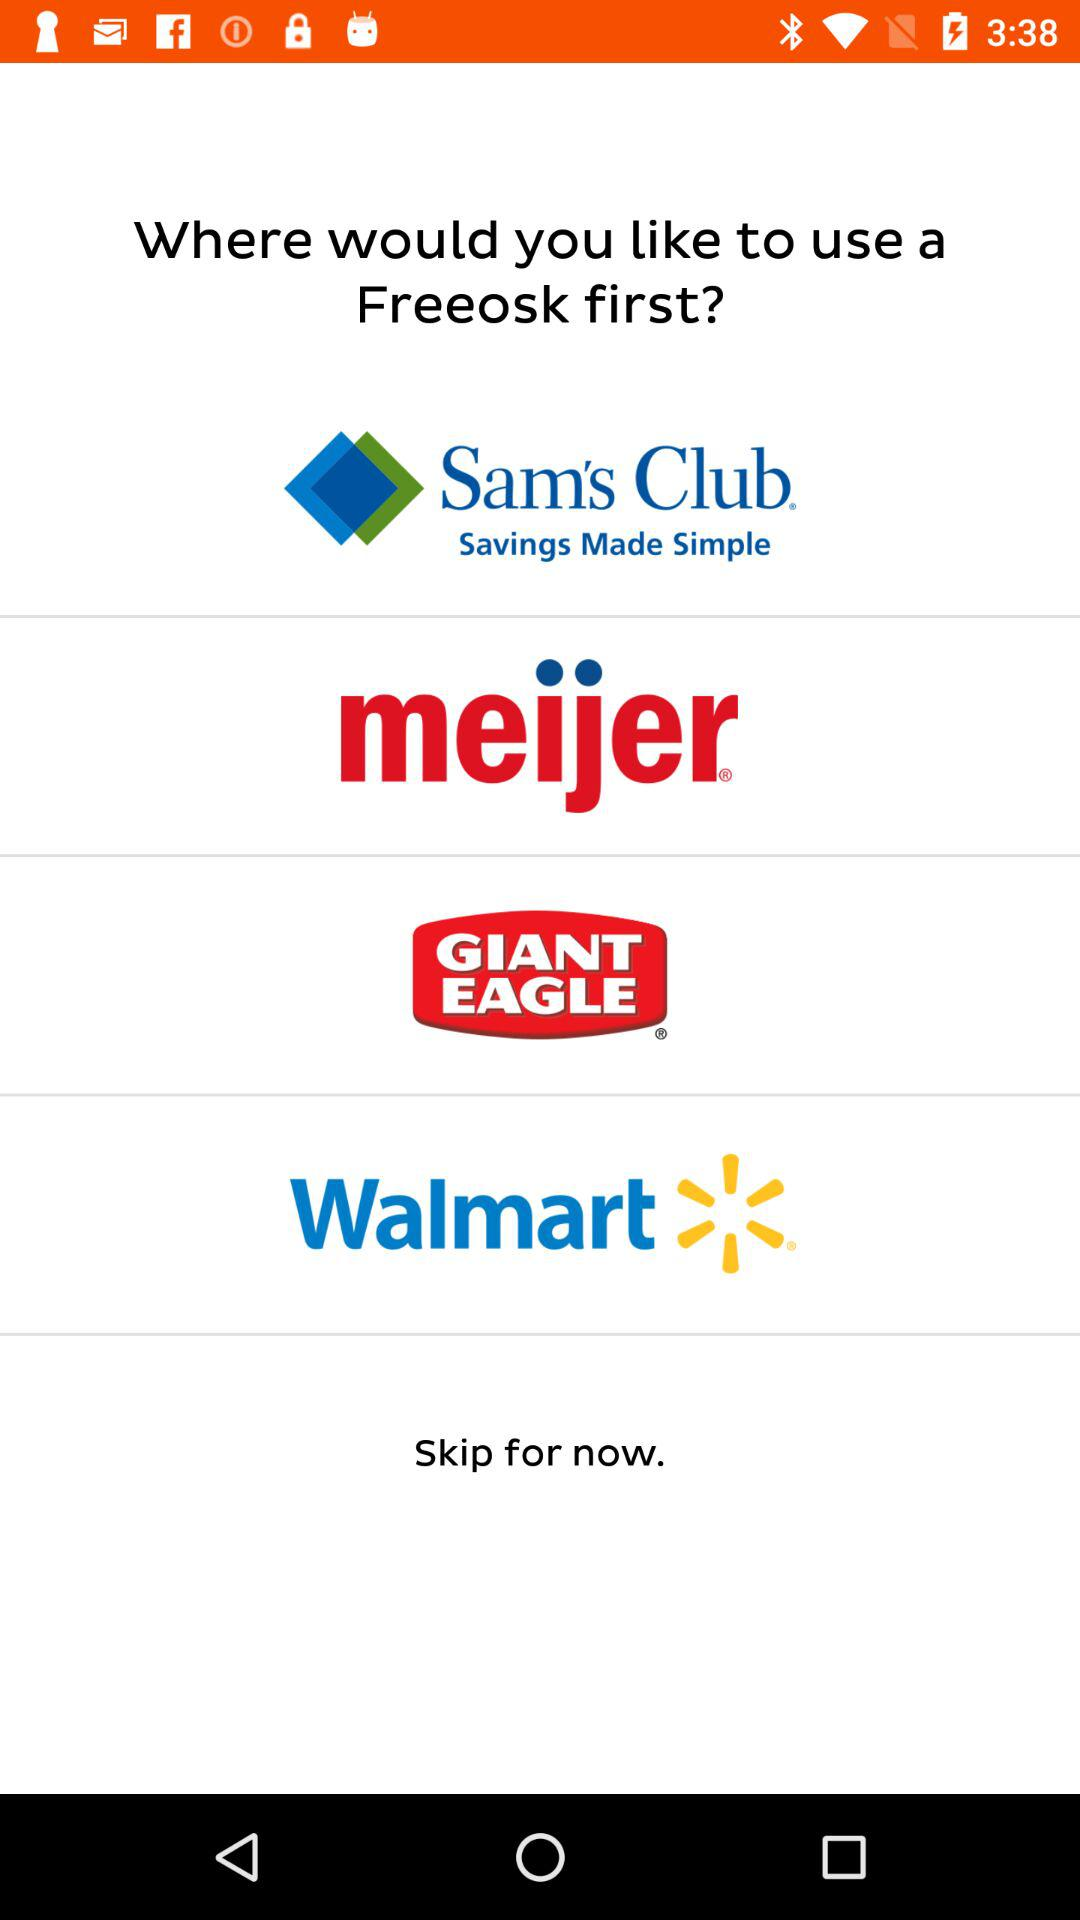Which options are there for using a "Freeosk" first? The options for using a "Freeosk" first are "Sam's Club", "meijer", "GIANT EAGLE" and "Walmart". 